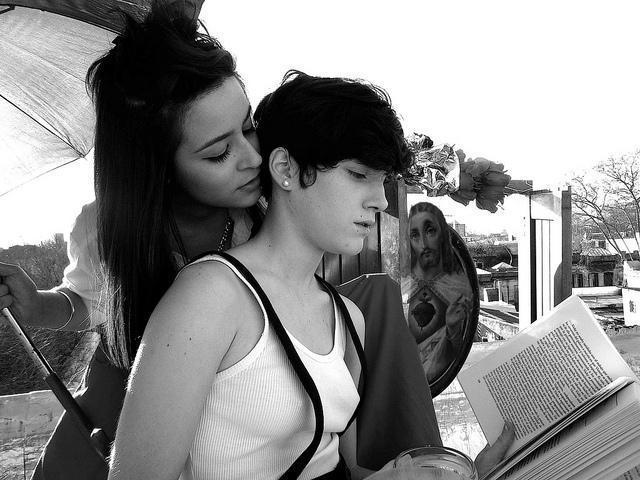How many people are there?
Give a very brief answer. 2. How many sheep are in the picture?
Give a very brief answer. 0. 